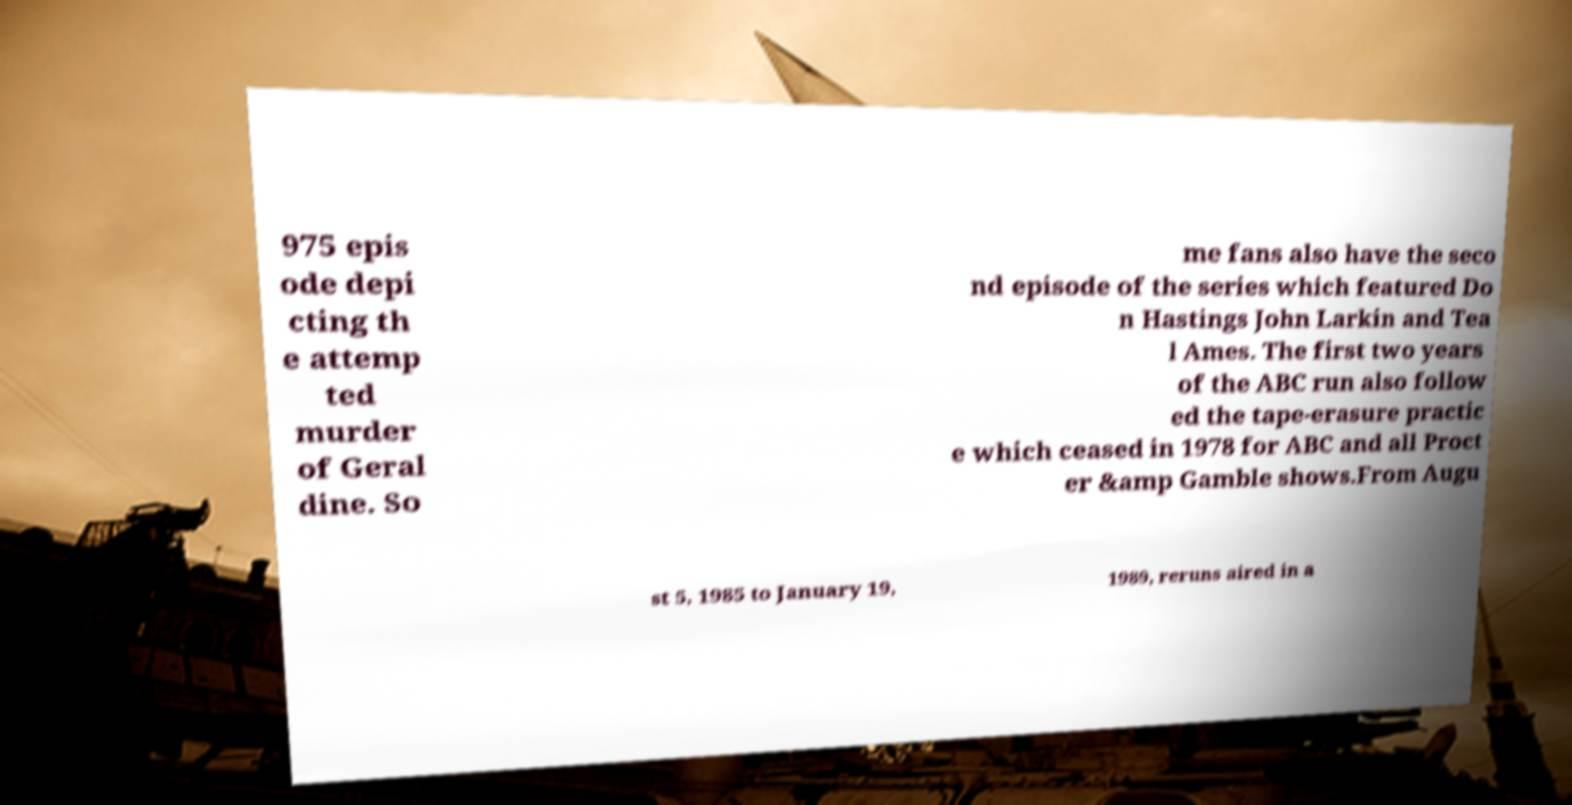What messages or text are displayed in this image? I need them in a readable, typed format. 975 epis ode depi cting th e attemp ted murder of Geral dine. So me fans also have the seco nd episode of the series which featured Do n Hastings John Larkin and Tea l Ames. The first two years of the ABC run also follow ed the tape-erasure practic e which ceased in 1978 for ABC and all Proct er &amp Gamble shows.From Augu st 5, 1985 to January 19, 1989, reruns aired in a 